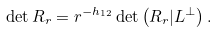<formula> <loc_0><loc_0><loc_500><loc_500>\det R _ { r } = r ^ { - h _ { 1 2 } } \det \left ( R _ { r } | L ^ { \perp } \right ) .</formula> 